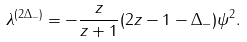Convert formula to latex. <formula><loc_0><loc_0><loc_500><loc_500>\lambda ^ { ( 2 \Delta _ { - } ) } = - \frac { z } { z + 1 } ( 2 z - 1 - \Delta _ { - } ) \psi ^ { 2 } .</formula> 